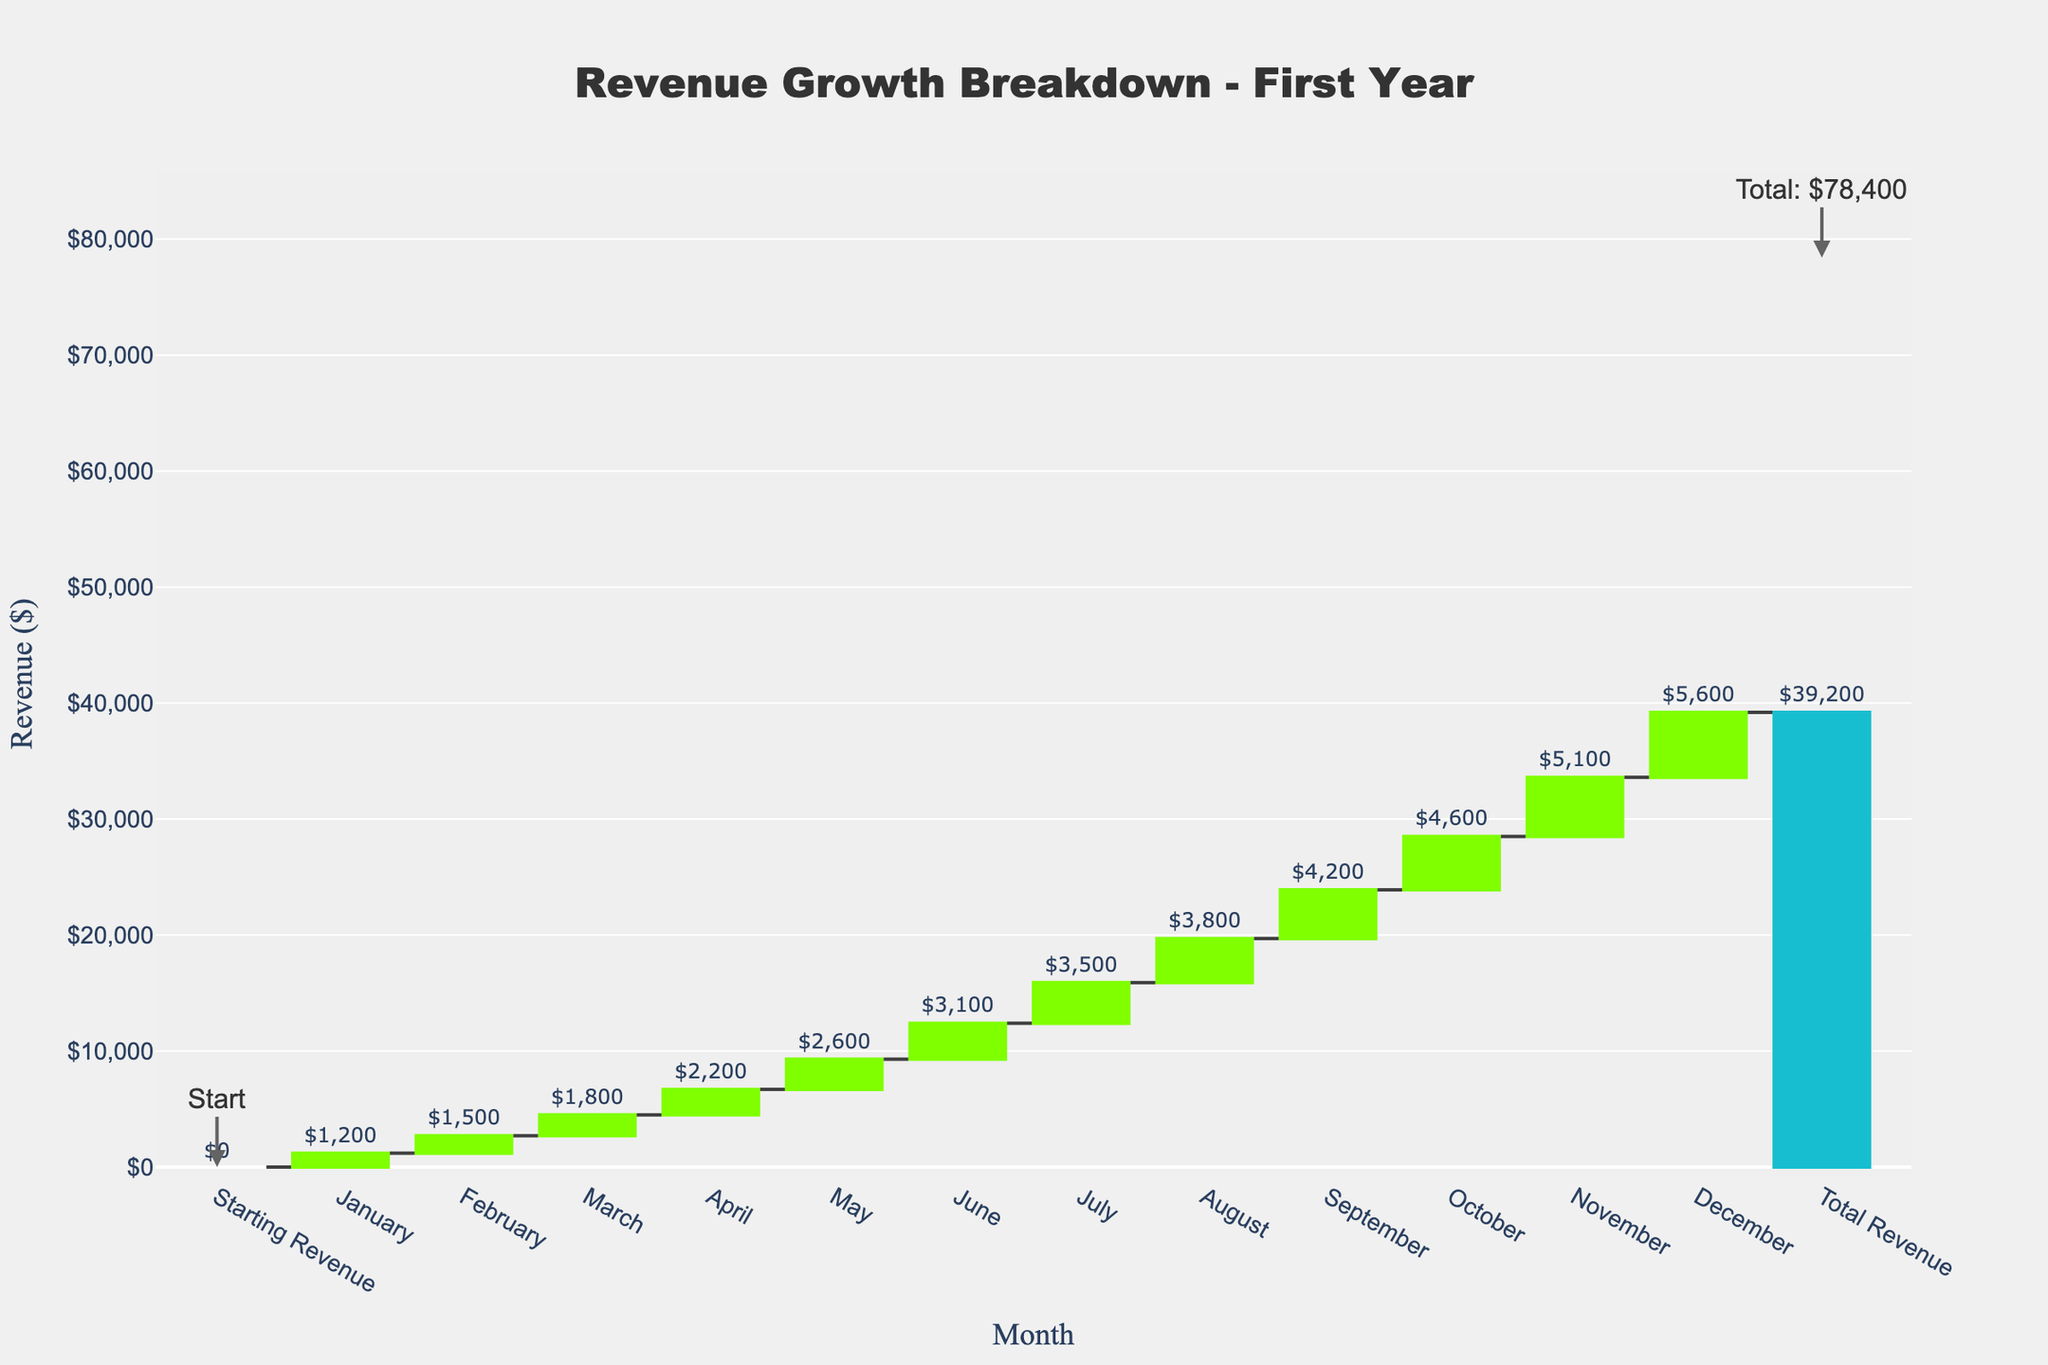What is the title of the chart? The title of the chart is displayed prominently at the top. It reads "Revenue Growth Breakdown - First Year."
Answer: Revenue Growth Breakdown - First Year What is the total revenue at the end of the year? At the far right of the chart, the bar labeled "Total Revenue" shows an annotation indicating the cumulative total revenue, which is $39,200.
Answer: $39,200 Which month had the highest revenue change? To determine this, observe the height of the bars labeled with each month's revenue change on the y-axis. The tallest monthly bar represents December with $5600.
Answer: December How much was the revenue change in June? Locate the bar corresponding to June on the x-axis and refer to the value annotated above it, which is $3100.
Answer: $3100 What was the total cumulative revenue by April? Sum the monthly revenues from January to April. The cumulative total is $1200 (Jan) + $1500 (Feb) + $1800 (Mar) + $2200 (Apr) = $6700.
Answer: $6700 Compare the revenue change between February and March. The height of the bar for February shows a $1500 change, while March shows an $1800 change. March had a higher revenue change compared to February.
Answer: March had a higher change Which month had the smallest revenue change? By examining the smallest bar in height among the months, January is identified with the smallest revenue change of $1200.
Answer: January How does the revenue change in November compare to October? The value for November is $5100 and for October is $4600. By subtracting October's change from November's, $5100 - $4600 = $500, November's change is $500 greater.
Answer: November had $500 more What is the average monthly revenue change? To find the average, sum all the monthly revenue changes and divide by the number of months. The sum is $1200 + $1500 + $1800 + $2200 + $2600 + $3100 + $3500 + $3800 + $4200 + $4600 + $5100 + $5600 = $39200. Dividing by 12 months gives $39200/12 ≈ $3266.67.
Answer: $3266.67 What is the significance of the annotations for "Starting Revenue" and "Total Revenue"? The annotations highlight the initial starting point and the final cumulative revenue, making it easier to understand the revenue progression over the year and the final total.
Answer: Indicates start and total revenue 